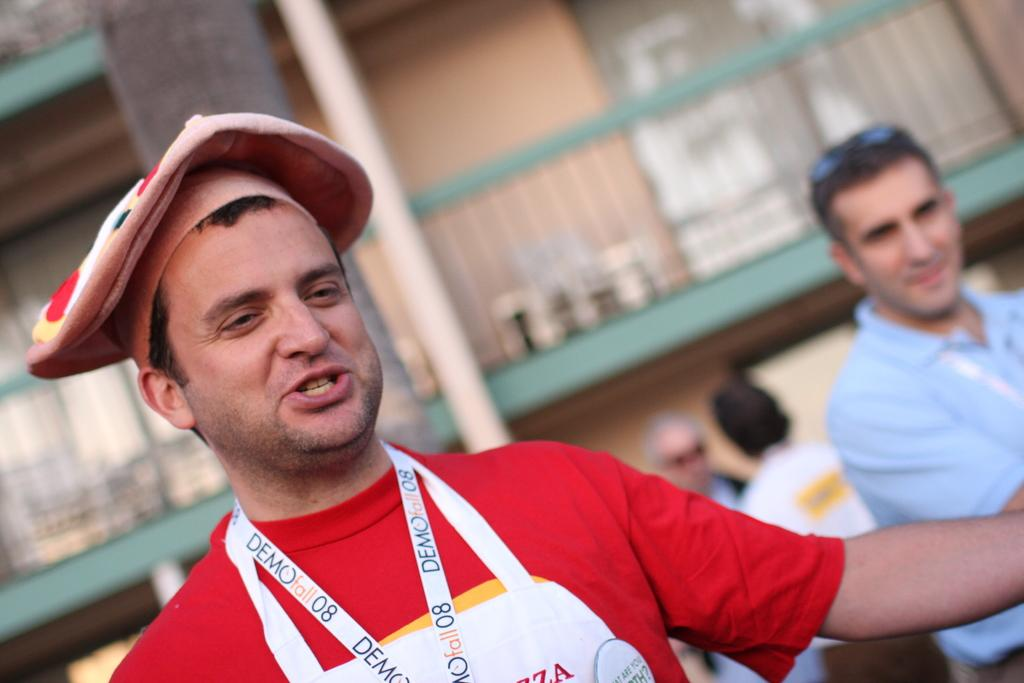<image>
Give a short and clear explanation of the subsequent image. The chef has Demo written on the lanyard around his neck. 